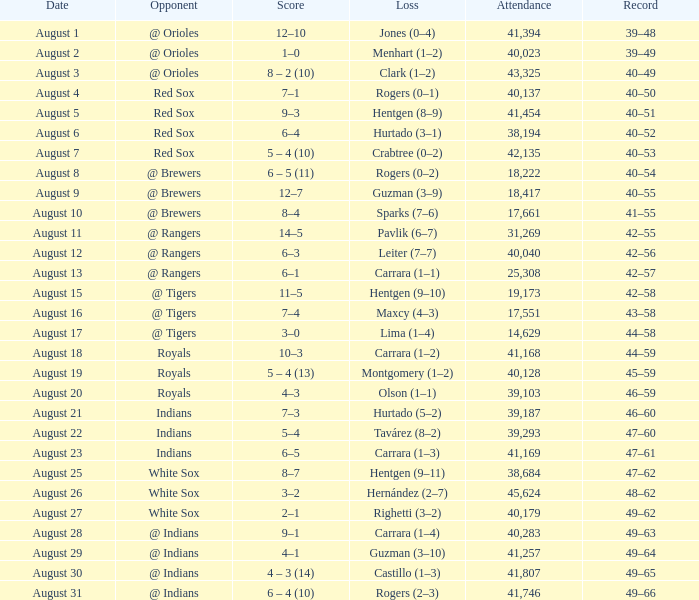Who did they play on August 12? @ Rangers. 